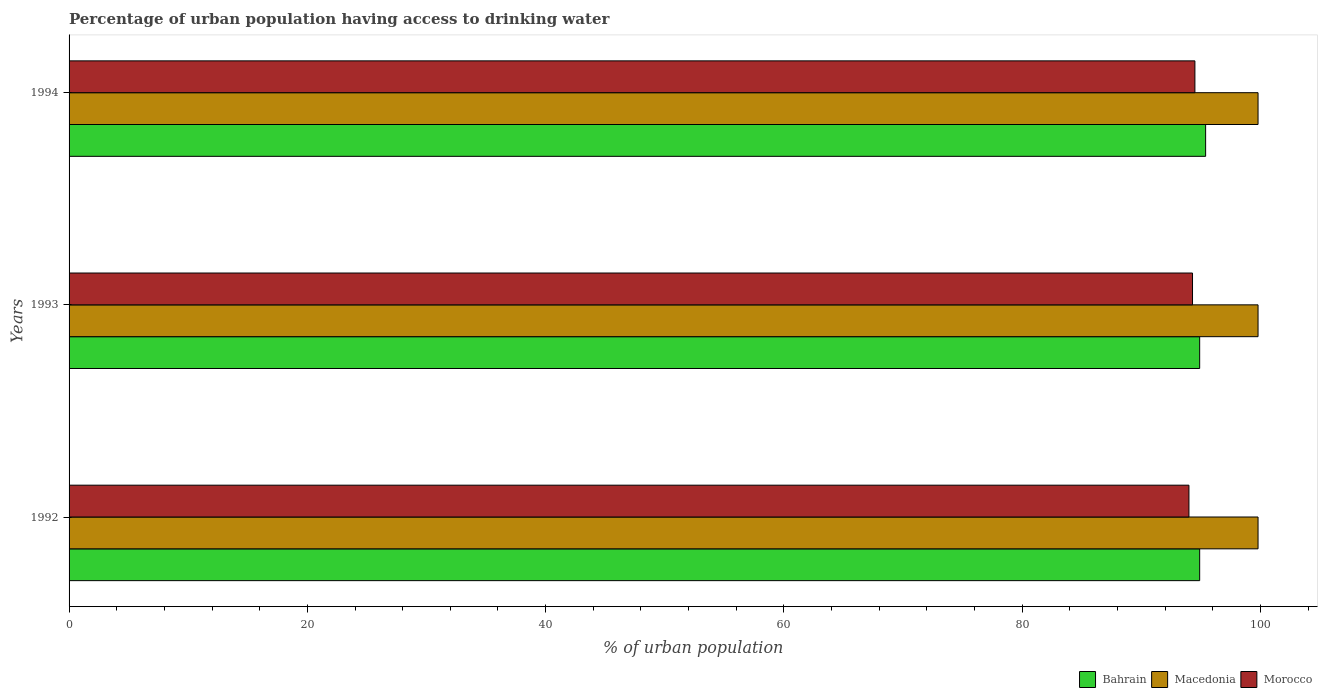How many different coloured bars are there?
Your response must be concise. 3. Are the number of bars on each tick of the Y-axis equal?
Provide a short and direct response. Yes. How many bars are there on the 1st tick from the bottom?
Give a very brief answer. 3. What is the label of the 3rd group of bars from the top?
Make the answer very short. 1992. What is the percentage of urban population having access to drinking water in Macedonia in 1993?
Offer a very short reply. 99.8. Across all years, what is the maximum percentage of urban population having access to drinking water in Macedonia?
Provide a succinct answer. 99.8. Across all years, what is the minimum percentage of urban population having access to drinking water in Bahrain?
Make the answer very short. 94.9. In which year was the percentage of urban population having access to drinking water in Morocco minimum?
Your response must be concise. 1992. What is the total percentage of urban population having access to drinking water in Morocco in the graph?
Provide a succinct answer. 282.8. What is the difference between the percentage of urban population having access to drinking water in Macedonia in 1993 and that in 1994?
Your answer should be very brief. 0. What is the difference between the percentage of urban population having access to drinking water in Morocco in 1992 and the percentage of urban population having access to drinking water in Macedonia in 1993?
Your answer should be compact. -5.8. What is the average percentage of urban population having access to drinking water in Macedonia per year?
Your response must be concise. 99.8. In the year 1994, what is the difference between the percentage of urban population having access to drinking water in Macedonia and percentage of urban population having access to drinking water in Morocco?
Ensure brevity in your answer.  5.3. Is the percentage of urban population having access to drinking water in Macedonia in 1993 less than that in 1994?
Your answer should be compact. No. Is the difference between the percentage of urban population having access to drinking water in Macedonia in 1992 and 1994 greater than the difference between the percentage of urban population having access to drinking water in Morocco in 1992 and 1994?
Ensure brevity in your answer.  Yes. What is the difference between the highest and the lowest percentage of urban population having access to drinking water in Morocco?
Make the answer very short. 0.5. What does the 3rd bar from the top in 1992 represents?
Offer a terse response. Bahrain. What does the 3rd bar from the bottom in 1992 represents?
Give a very brief answer. Morocco. Is it the case that in every year, the sum of the percentage of urban population having access to drinking water in Bahrain and percentage of urban population having access to drinking water in Macedonia is greater than the percentage of urban population having access to drinking water in Morocco?
Your response must be concise. Yes. How many bars are there?
Ensure brevity in your answer.  9. Are all the bars in the graph horizontal?
Keep it short and to the point. Yes. Does the graph contain any zero values?
Keep it short and to the point. No. How many legend labels are there?
Your answer should be compact. 3. How are the legend labels stacked?
Provide a succinct answer. Horizontal. What is the title of the graph?
Offer a terse response. Percentage of urban population having access to drinking water. Does "Sierra Leone" appear as one of the legend labels in the graph?
Ensure brevity in your answer.  No. What is the label or title of the X-axis?
Offer a terse response. % of urban population. What is the % of urban population of Bahrain in 1992?
Offer a very short reply. 94.9. What is the % of urban population of Macedonia in 1992?
Ensure brevity in your answer.  99.8. What is the % of urban population of Morocco in 1992?
Your answer should be compact. 94. What is the % of urban population of Bahrain in 1993?
Give a very brief answer. 94.9. What is the % of urban population of Macedonia in 1993?
Offer a very short reply. 99.8. What is the % of urban population of Morocco in 1993?
Give a very brief answer. 94.3. What is the % of urban population in Bahrain in 1994?
Your answer should be very brief. 95.4. What is the % of urban population in Macedonia in 1994?
Your response must be concise. 99.8. What is the % of urban population of Morocco in 1994?
Ensure brevity in your answer.  94.5. Across all years, what is the maximum % of urban population in Bahrain?
Make the answer very short. 95.4. Across all years, what is the maximum % of urban population in Macedonia?
Keep it short and to the point. 99.8. Across all years, what is the maximum % of urban population of Morocco?
Provide a succinct answer. 94.5. Across all years, what is the minimum % of urban population of Bahrain?
Your response must be concise. 94.9. Across all years, what is the minimum % of urban population of Macedonia?
Offer a terse response. 99.8. Across all years, what is the minimum % of urban population of Morocco?
Provide a short and direct response. 94. What is the total % of urban population in Bahrain in the graph?
Your response must be concise. 285.2. What is the total % of urban population in Macedonia in the graph?
Give a very brief answer. 299.4. What is the total % of urban population of Morocco in the graph?
Offer a very short reply. 282.8. What is the difference between the % of urban population in Bahrain in 1992 and that in 1993?
Your answer should be very brief. 0. What is the difference between the % of urban population in Macedonia in 1993 and that in 1994?
Provide a short and direct response. 0. What is the difference between the % of urban population in Bahrain in 1992 and the % of urban population in Macedonia in 1993?
Your answer should be compact. -4.9. What is the difference between the % of urban population of Bahrain in 1992 and the % of urban population of Morocco in 1993?
Offer a terse response. 0.6. What is the difference between the % of urban population of Bahrain in 1992 and the % of urban population of Morocco in 1994?
Keep it short and to the point. 0.4. What is the difference between the % of urban population of Bahrain in 1993 and the % of urban population of Macedonia in 1994?
Offer a terse response. -4.9. What is the difference between the % of urban population in Bahrain in 1993 and the % of urban population in Morocco in 1994?
Keep it short and to the point. 0.4. What is the average % of urban population of Bahrain per year?
Give a very brief answer. 95.07. What is the average % of urban population of Macedonia per year?
Provide a short and direct response. 99.8. What is the average % of urban population in Morocco per year?
Your answer should be compact. 94.27. In the year 1992, what is the difference between the % of urban population in Bahrain and % of urban population in Macedonia?
Ensure brevity in your answer.  -4.9. In the year 1993, what is the difference between the % of urban population in Bahrain and % of urban population in Macedonia?
Your answer should be very brief. -4.9. In the year 1994, what is the difference between the % of urban population of Bahrain and % of urban population of Macedonia?
Ensure brevity in your answer.  -4.4. In the year 1994, what is the difference between the % of urban population in Bahrain and % of urban population in Morocco?
Keep it short and to the point. 0.9. What is the ratio of the % of urban population of Morocco in 1992 to that in 1993?
Your answer should be very brief. 1. What is the ratio of the % of urban population in Bahrain in 1992 to that in 1994?
Provide a succinct answer. 0.99. What is the ratio of the % of urban population in Macedonia in 1992 to that in 1994?
Give a very brief answer. 1. What is the ratio of the % of urban population of Bahrain in 1993 to that in 1994?
Keep it short and to the point. 0.99. What is the ratio of the % of urban population in Macedonia in 1993 to that in 1994?
Your response must be concise. 1. What is the ratio of the % of urban population of Morocco in 1993 to that in 1994?
Ensure brevity in your answer.  1. What is the difference between the highest and the second highest % of urban population of Bahrain?
Offer a very short reply. 0.5. What is the difference between the highest and the second highest % of urban population of Macedonia?
Provide a succinct answer. 0. What is the difference between the highest and the second highest % of urban population of Morocco?
Ensure brevity in your answer.  0.2. What is the difference between the highest and the lowest % of urban population in Bahrain?
Ensure brevity in your answer.  0.5. What is the difference between the highest and the lowest % of urban population of Macedonia?
Your response must be concise. 0. What is the difference between the highest and the lowest % of urban population in Morocco?
Your answer should be very brief. 0.5. 